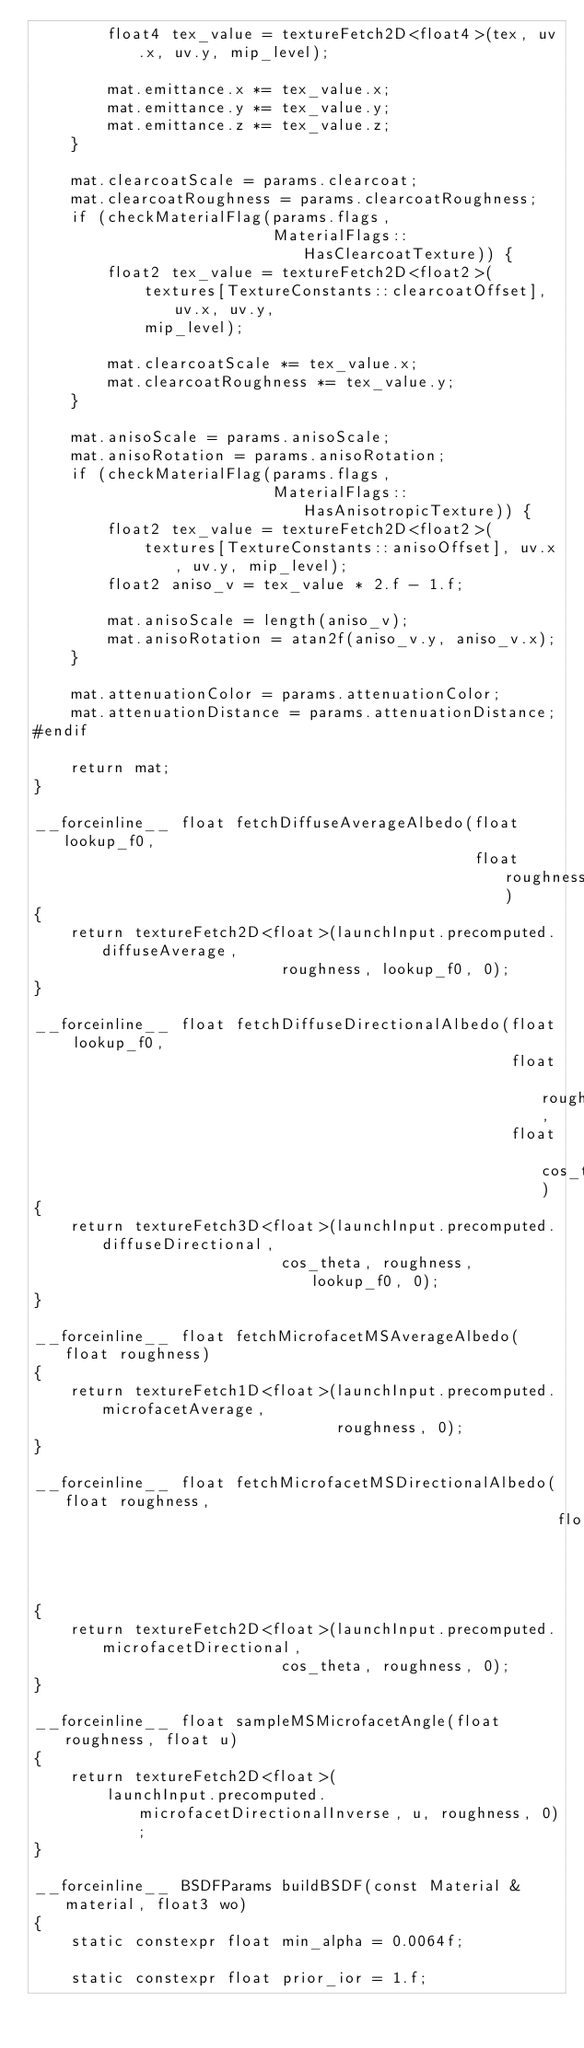Convert code to text. <code><loc_0><loc_0><loc_500><loc_500><_Cuda_>        float4 tex_value = textureFetch2D<float4>(tex, uv.x, uv.y, mip_level);

        mat.emittance.x *= tex_value.x;
        mat.emittance.y *= tex_value.y;
        mat.emittance.z *= tex_value.z;
    }

    mat.clearcoatScale = params.clearcoat;
    mat.clearcoatRoughness = params.clearcoatRoughness;
    if (checkMaterialFlag(params.flags,
                          MaterialFlags::HasClearcoatTexture)) {
        float2 tex_value = textureFetch2D<float2>(
            textures[TextureConstants::clearcoatOffset], uv.x, uv.y,
            mip_level);

        mat.clearcoatScale *= tex_value.x;
        mat.clearcoatRoughness *= tex_value.y;
    }

    mat.anisoScale = params.anisoScale;
    mat.anisoRotation = params.anisoRotation;
    if (checkMaterialFlag(params.flags,
                          MaterialFlags::HasAnisotropicTexture)) {
        float2 tex_value = textureFetch2D<float2>(
            textures[TextureConstants::anisoOffset], uv.x, uv.y, mip_level);
        float2 aniso_v = tex_value * 2.f - 1.f;

        mat.anisoScale = length(aniso_v);
        mat.anisoRotation = atan2f(aniso_v.y, aniso_v.x);
    }

    mat.attenuationColor = params.attenuationColor;
    mat.attenuationDistance = params.attenuationDistance;
#endif

    return mat;
}

__forceinline__ float fetchDiffuseAverageAlbedo(float lookup_f0,
                                                float roughness)
{
    return textureFetch2D<float>(launchInput.precomputed.diffuseAverage,
                           roughness, lookup_f0, 0);
}

__forceinline__ float fetchDiffuseDirectionalAlbedo(float lookup_f0,
                                                    float roughness,
                                                    float cos_theta)
{
    return textureFetch3D<float>(launchInput.precomputed.diffuseDirectional,
                           cos_theta, roughness, lookup_f0, 0);
}

__forceinline__ float fetchMicrofacetMSAverageAlbedo(float roughness)
{
    return textureFetch1D<float>(launchInput.precomputed.microfacetAverage,
                                 roughness, 0);
}

__forceinline__ float fetchMicrofacetMSDirectionalAlbedo(float roughness,
                                                         float cos_theta)
{
    return textureFetch2D<float>(launchInput.precomputed.microfacetDirectional,
                           cos_theta, roughness, 0);
}

__forceinline__ float sampleMSMicrofacetAngle(float roughness, float u)
{
    return textureFetch2D<float>(
        launchInput.precomputed.microfacetDirectionalInverse, u, roughness, 0);
}

__forceinline__ BSDFParams buildBSDF(const Material &material, float3 wo)
{
    static constexpr float min_alpha = 0.0064f;

    static constexpr float prior_ior = 1.f;</code> 